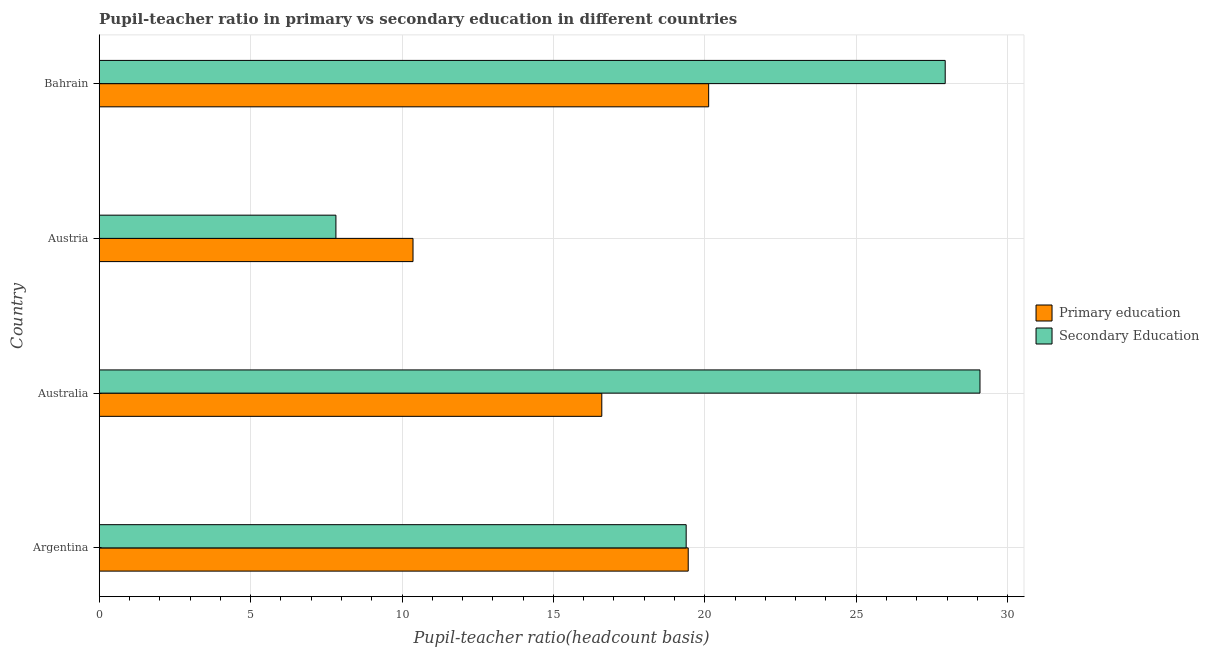Are the number of bars per tick equal to the number of legend labels?
Your answer should be very brief. Yes. Are the number of bars on each tick of the Y-axis equal?
Offer a terse response. Yes. What is the label of the 1st group of bars from the top?
Offer a very short reply. Bahrain. What is the pupil-teacher ratio in primary education in Bahrain?
Provide a succinct answer. 20.13. Across all countries, what is the maximum pupil-teacher ratio in primary education?
Provide a short and direct response. 20.13. Across all countries, what is the minimum pupil-teacher ratio in primary education?
Make the answer very short. 10.36. In which country was the pupil-teacher ratio in primary education maximum?
Your answer should be very brief. Bahrain. In which country was the pupil teacher ratio on secondary education minimum?
Your answer should be very brief. Austria. What is the total pupil teacher ratio on secondary education in the graph?
Your answer should be compact. 84.23. What is the difference between the pupil-teacher ratio in primary education in Argentina and that in Austria?
Your answer should be very brief. 9.09. What is the difference between the pupil teacher ratio on secondary education in Australia and the pupil-teacher ratio in primary education in Bahrain?
Your answer should be very brief. 8.96. What is the average pupil teacher ratio on secondary education per country?
Offer a very short reply. 21.06. What is the difference between the pupil-teacher ratio in primary education and pupil teacher ratio on secondary education in Bahrain?
Offer a very short reply. -7.81. What is the ratio of the pupil teacher ratio on secondary education in Argentina to that in Bahrain?
Your answer should be very brief. 0.69. Is the pupil teacher ratio on secondary education in Australia less than that in Bahrain?
Offer a terse response. No. Is the difference between the pupil-teacher ratio in primary education in Austria and Bahrain greater than the difference between the pupil teacher ratio on secondary education in Austria and Bahrain?
Give a very brief answer. Yes. What is the difference between the highest and the second highest pupil-teacher ratio in primary education?
Provide a succinct answer. 0.68. What is the difference between the highest and the lowest pupil teacher ratio on secondary education?
Your answer should be compact. 21.27. In how many countries, is the pupil teacher ratio on secondary education greater than the average pupil teacher ratio on secondary education taken over all countries?
Offer a very short reply. 2. Is the sum of the pupil teacher ratio on secondary education in Argentina and Austria greater than the maximum pupil-teacher ratio in primary education across all countries?
Ensure brevity in your answer.  Yes. What does the 2nd bar from the top in Austria represents?
Ensure brevity in your answer.  Primary education. What does the 2nd bar from the bottom in Argentina represents?
Provide a succinct answer. Secondary Education. Are all the bars in the graph horizontal?
Offer a very short reply. Yes. How many countries are there in the graph?
Your answer should be compact. 4. Are the values on the major ticks of X-axis written in scientific E-notation?
Make the answer very short. No. How many legend labels are there?
Provide a succinct answer. 2. How are the legend labels stacked?
Your answer should be very brief. Vertical. What is the title of the graph?
Keep it short and to the point. Pupil-teacher ratio in primary vs secondary education in different countries. Does "International Tourists" appear as one of the legend labels in the graph?
Your answer should be compact. No. What is the label or title of the X-axis?
Offer a terse response. Pupil-teacher ratio(headcount basis). What is the label or title of the Y-axis?
Provide a short and direct response. Country. What is the Pupil-teacher ratio(headcount basis) in Primary education in Argentina?
Provide a succinct answer. 19.45. What is the Pupil-teacher ratio(headcount basis) of Secondary Education in Argentina?
Your answer should be compact. 19.38. What is the Pupil-teacher ratio(headcount basis) in Primary education in Australia?
Provide a short and direct response. 16.6. What is the Pupil-teacher ratio(headcount basis) in Secondary Education in Australia?
Give a very brief answer. 29.09. What is the Pupil-teacher ratio(headcount basis) in Primary education in Austria?
Your answer should be compact. 10.36. What is the Pupil-teacher ratio(headcount basis) of Secondary Education in Austria?
Offer a terse response. 7.82. What is the Pupil-teacher ratio(headcount basis) in Primary education in Bahrain?
Keep it short and to the point. 20.13. What is the Pupil-teacher ratio(headcount basis) in Secondary Education in Bahrain?
Your response must be concise. 27.94. Across all countries, what is the maximum Pupil-teacher ratio(headcount basis) of Primary education?
Keep it short and to the point. 20.13. Across all countries, what is the maximum Pupil-teacher ratio(headcount basis) of Secondary Education?
Offer a very short reply. 29.09. Across all countries, what is the minimum Pupil-teacher ratio(headcount basis) of Primary education?
Your answer should be compact. 10.36. Across all countries, what is the minimum Pupil-teacher ratio(headcount basis) of Secondary Education?
Keep it short and to the point. 7.82. What is the total Pupil-teacher ratio(headcount basis) in Primary education in the graph?
Offer a terse response. 66.54. What is the total Pupil-teacher ratio(headcount basis) of Secondary Education in the graph?
Your answer should be very brief. 84.23. What is the difference between the Pupil-teacher ratio(headcount basis) in Primary education in Argentina and that in Australia?
Your answer should be very brief. 2.85. What is the difference between the Pupil-teacher ratio(headcount basis) of Secondary Education in Argentina and that in Australia?
Your answer should be compact. -9.7. What is the difference between the Pupil-teacher ratio(headcount basis) of Primary education in Argentina and that in Austria?
Provide a succinct answer. 9.09. What is the difference between the Pupil-teacher ratio(headcount basis) of Secondary Education in Argentina and that in Austria?
Your answer should be very brief. 11.57. What is the difference between the Pupil-teacher ratio(headcount basis) in Primary education in Argentina and that in Bahrain?
Offer a terse response. -0.67. What is the difference between the Pupil-teacher ratio(headcount basis) of Secondary Education in Argentina and that in Bahrain?
Provide a succinct answer. -8.55. What is the difference between the Pupil-teacher ratio(headcount basis) in Primary education in Australia and that in Austria?
Provide a short and direct response. 6.23. What is the difference between the Pupil-teacher ratio(headcount basis) of Secondary Education in Australia and that in Austria?
Provide a short and direct response. 21.27. What is the difference between the Pupil-teacher ratio(headcount basis) in Primary education in Australia and that in Bahrain?
Your answer should be very brief. -3.53. What is the difference between the Pupil-teacher ratio(headcount basis) of Secondary Education in Australia and that in Bahrain?
Make the answer very short. 1.15. What is the difference between the Pupil-teacher ratio(headcount basis) in Primary education in Austria and that in Bahrain?
Your answer should be compact. -9.76. What is the difference between the Pupil-teacher ratio(headcount basis) of Secondary Education in Austria and that in Bahrain?
Your answer should be compact. -20.12. What is the difference between the Pupil-teacher ratio(headcount basis) in Primary education in Argentina and the Pupil-teacher ratio(headcount basis) in Secondary Education in Australia?
Your answer should be compact. -9.64. What is the difference between the Pupil-teacher ratio(headcount basis) of Primary education in Argentina and the Pupil-teacher ratio(headcount basis) of Secondary Education in Austria?
Give a very brief answer. 11.63. What is the difference between the Pupil-teacher ratio(headcount basis) in Primary education in Argentina and the Pupil-teacher ratio(headcount basis) in Secondary Education in Bahrain?
Offer a very short reply. -8.49. What is the difference between the Pupil-teacher ratio(headcount basis) in Primary education in Australia and the Pupil-teacher ratio(headcount basis) in Secondary Education in Austria?
Make the answer very short. 8.78. What is the difference between the Pupil-teacher ratio(headcount basis) in Primary education in Australia and the Pupil-teacher ratio(headcount basis) in Secondary Education in Bahrain?
Offer a very short reply. -11.34. What is the difference between the Pupil-teacher ratio(headcount basis) of Primary education in Austria and the Pupil-teacher ratio(headcount basis) of Secondary Education in Bahrain?
Ensure brevity in your answer.  -17.58. What is the average Pupil-teacher ratio(headcount basis) of Primary education per country?
Your response must be concise. 16.63. What is the average Pupil-teacher ratio(headcount basis) in Secondary Education per country?
Offer a terse response. 21.06. What is the difference between the Pupil-teacher ratio(headcount basis) in Primary education and Pupil-teacher ratio(headcount basis) in Secondary Education in Argentina?
Offer a very short reply. 0.07. What is the difference between the Pupil-teacher ratio(headcount basis) in Primary education and Pupil-teacher ratio(headcount basis) in Secondary Education in Australia?
Keep it short and to the point. -12.49. What is the difference between the Pupil-teacher ratio(headcount basis) of Primary education and Pupil-teacher ratio(headcount basis) of Secondary Education in Austria?
Offer a very short reply. 2.55. What is the difference between the Pupil-teacher ratio(headcount basis) in Primary education and Pupil-teacher ratio(headcount basis) in Secondary Education in Bahrain?
Your response must be concise. -7.81. What is the ratio of the Pupil-teacher ratio(headcount basis) in Primary education in Argentina to that in Australia?
Your response must be concise. 1.17. What is the ratio of the Pupil-teacher ratio(headcount basis) in Secondary Education in Argentina to that in Australia?
Offer a very short reply. 0.67. What is the ratio of the Pupil-teacher ratio(headcount basis) of Primary education in Argentina to that in Austria?
Your answer should be compact. 1.88. What is the ratio of the Pupil-teacher ratio(headcount basis) in Secondary Education in Argentina to that in Austria?
Ensure brevity in your answer.  2.48. What is the ratio of the Pupil-teacher ratio(headcount basis) in Primary education in Argentina to that in Bahrain?
Make the answer very short. 0.97. What is the ratio of the Pupil-teacher ratio(headcount basis) in Secondary Education in Argentina to that in Bahrain?
Your answer should be very brief. 0.69. What is the ratio of the Pupil-teacher ratio(headcount basis) of Primary education in Australia to that in Austria?
Make the answer very short. 1.6. What is the ratio of the Pupil-teacher ratio(headcount basis) of Secondary Education in Australia to that in Austria?
Your answer should be very brief. 3.72. What is the ratio of the Pupil-teacher ratio(headcount basis) of Primary education in Australia to that in Bahrain?
Keep it short and to the point. 0.82. What is the ratio of the Pupil-teacher ratio(headcount basis) in Secondary Education in Australia to that in Bahrain?
Provide a succinct answer. 1.04. What is the ratio of the Pupil-teacher ratio(headcount basis) in Primary education in Austria to that in Bahrain?
Ensure brevity in your answer.  0.51. What is the ratio of the Pupil-teacher ratio(headcount basis) in Secondary Education in Austria to that in Bahrain?
Offer a very short reply. 0.28. What is the difference between the highest and the second highest Pupil-teacher ratio(headcount basis) of Primary education?
Offer a very short reply. 0.67. What is the difference between the highest and the second highest Pupil-teacher ratio(headcount basis) in Secondary Education?
Your answer should be very brief. 1.15. What is the difference between the highest and the lowest Pupil-teacher ratio(headcount basis) of Primary education?
Ensure brevity in your answer.  9.76. What is the difference between the highest and the lowest Pupil-teacher ratio(headcount basis) in Secondary Education?
Provide a short and direct response. 21.27. 